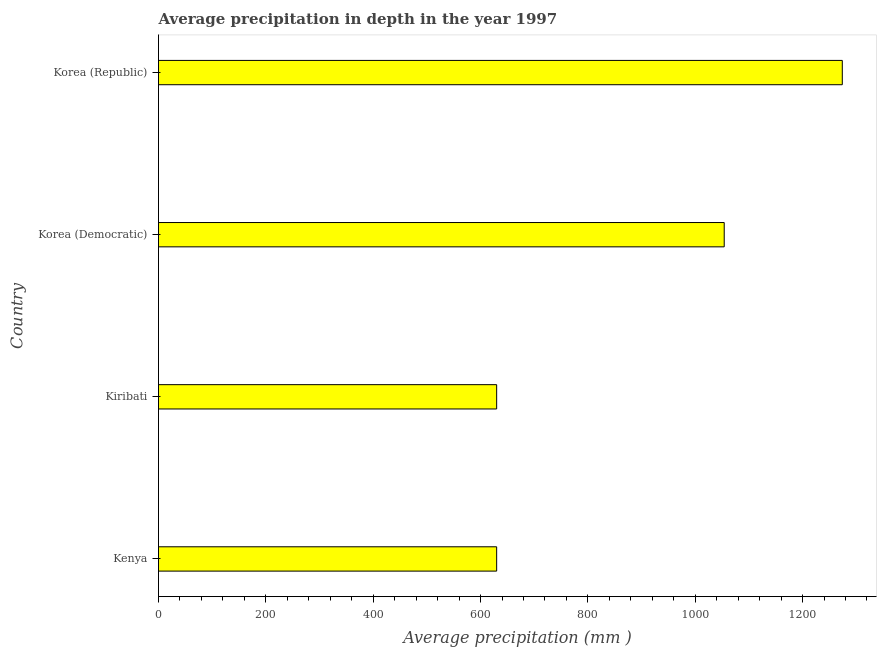Does the graph contain any zero values?
Ensure brevity in your answer.  No. What is the title of the graph?
Give a very brief answer. Average precipitation in depth in the year 1997. What is the label or title of the X-axis?
Your answer should be compact. Average precipitation (mm ). What is the label or title of the Y-axis?
Your answer should be very brief. Country. What is the average precipitation in depth in Kenya?
Give a very brief answer. 630. Across all countries, what is the maximum average precipitation in depth?
Your answer should be very brief. 1274. Across all countries, what is the minimum average precipitation in depth?
Ensure brevity in your answer.  630. In which country was the average precipitation in depth maximum?
Provide a succinct answer. Korea (Republic). In which country was the average precipitation in depth minimum?
Provide a succinct answer. Kenya. What is the sum of the average precipitation in depth?
Provide a short and direct response. 3588. What is the difference between the average precipitation in depth in Korea (Democratic) and Korea (Republic)?
Offer a very short reply. -220. What is the average average precipitation in depth per country?
Make the answer very short. 897. What is the median average precipitation in depth?
Give a very brief answer. 842. In how many countries, is the average precipitation in depth greater than 360 mm?
Give a very brief answer. 4. What is the ratio of the average precipitation in depth in Kenya to that in Korea (Democratic)?
Offer a terse response. 0.6. What is the difference between the highest and the second highest average precipitation in depth?
Offer a very short reply. 220. Is the sum of the average precipitation in depth in Kiribati and Korea (Democratic) greater than the maximum average precipitation in depth across all countries?
Give a very brief answer. Yes. What is the difference between the highest and the lowest average precipitation in depth?
Make the answer very short. 644. How many bars are there?
Provide a succinct answer. 4. How many countries are there in the graph?
Your answer should be very brief. 4. What is the difference between two consecutive major ticks on the X-axis?
Your answer should be compact. 200. Are the values on the major ticks of X-axis written in scientific E-notation?
Your response must be concise. No. What is the Average precipitation (mm ) in Kenya?
Offer a very short reply. 630. What is the Average precipitation (mm ) in Kiribati?
Give a very brief answer. 630. What is the Average precipitation (mm ) in Korea (Democratic)?
Give a very brief answer. 1054. What is the Average precipitation (mm ) in Korea (Republic)?
Offer a terse response. 1274. What is the difference between the Average precipitation (mm ) in Kenya and Korea (Democratic)?
Provide a succinct answer. -424. What is the difference between the Average precipitation (mm ) in Kenya and Korea (Republic)?
Ensure brevity in your answer.  -644. What is the difference between the Average precipitation (mm ) in Kiribati and Korea (Democratic)?
Provide a succinct answer. -424. What is the difference between the Average precipitation (mm ) in Kiribati and Korea (Republic)?
Give a very brief answer. -644. What is the difference between the Average precipitation (mm ) in Korea (Democratic) and Korea (Republic)?
Make the answer very short. -220. What is the ratio of the Average precipitation (mm ) in Kenya to that in Korea (Democratic)?
Your answer should be compact. 0.6. What is the ratio of the Average precipitation (mm ) in Kenya to that in Korea (Republic)?
Your answer should be compact. 0.49. What is the ratio of the Average precipitation (mm ) in Kiribati to that in Korea (Democratic)?
Make the answer very short. 0.6. What is the ratio of the Average precipitation (mm ) in Kiribati to that in Korea (Republic)?
Make the answer very short. 0.49. What is the ratio of the Average precipitation (mm ) in Korea (Democratic) to that in Korea (Republic)?
Your answer should be compact. 0.83. 